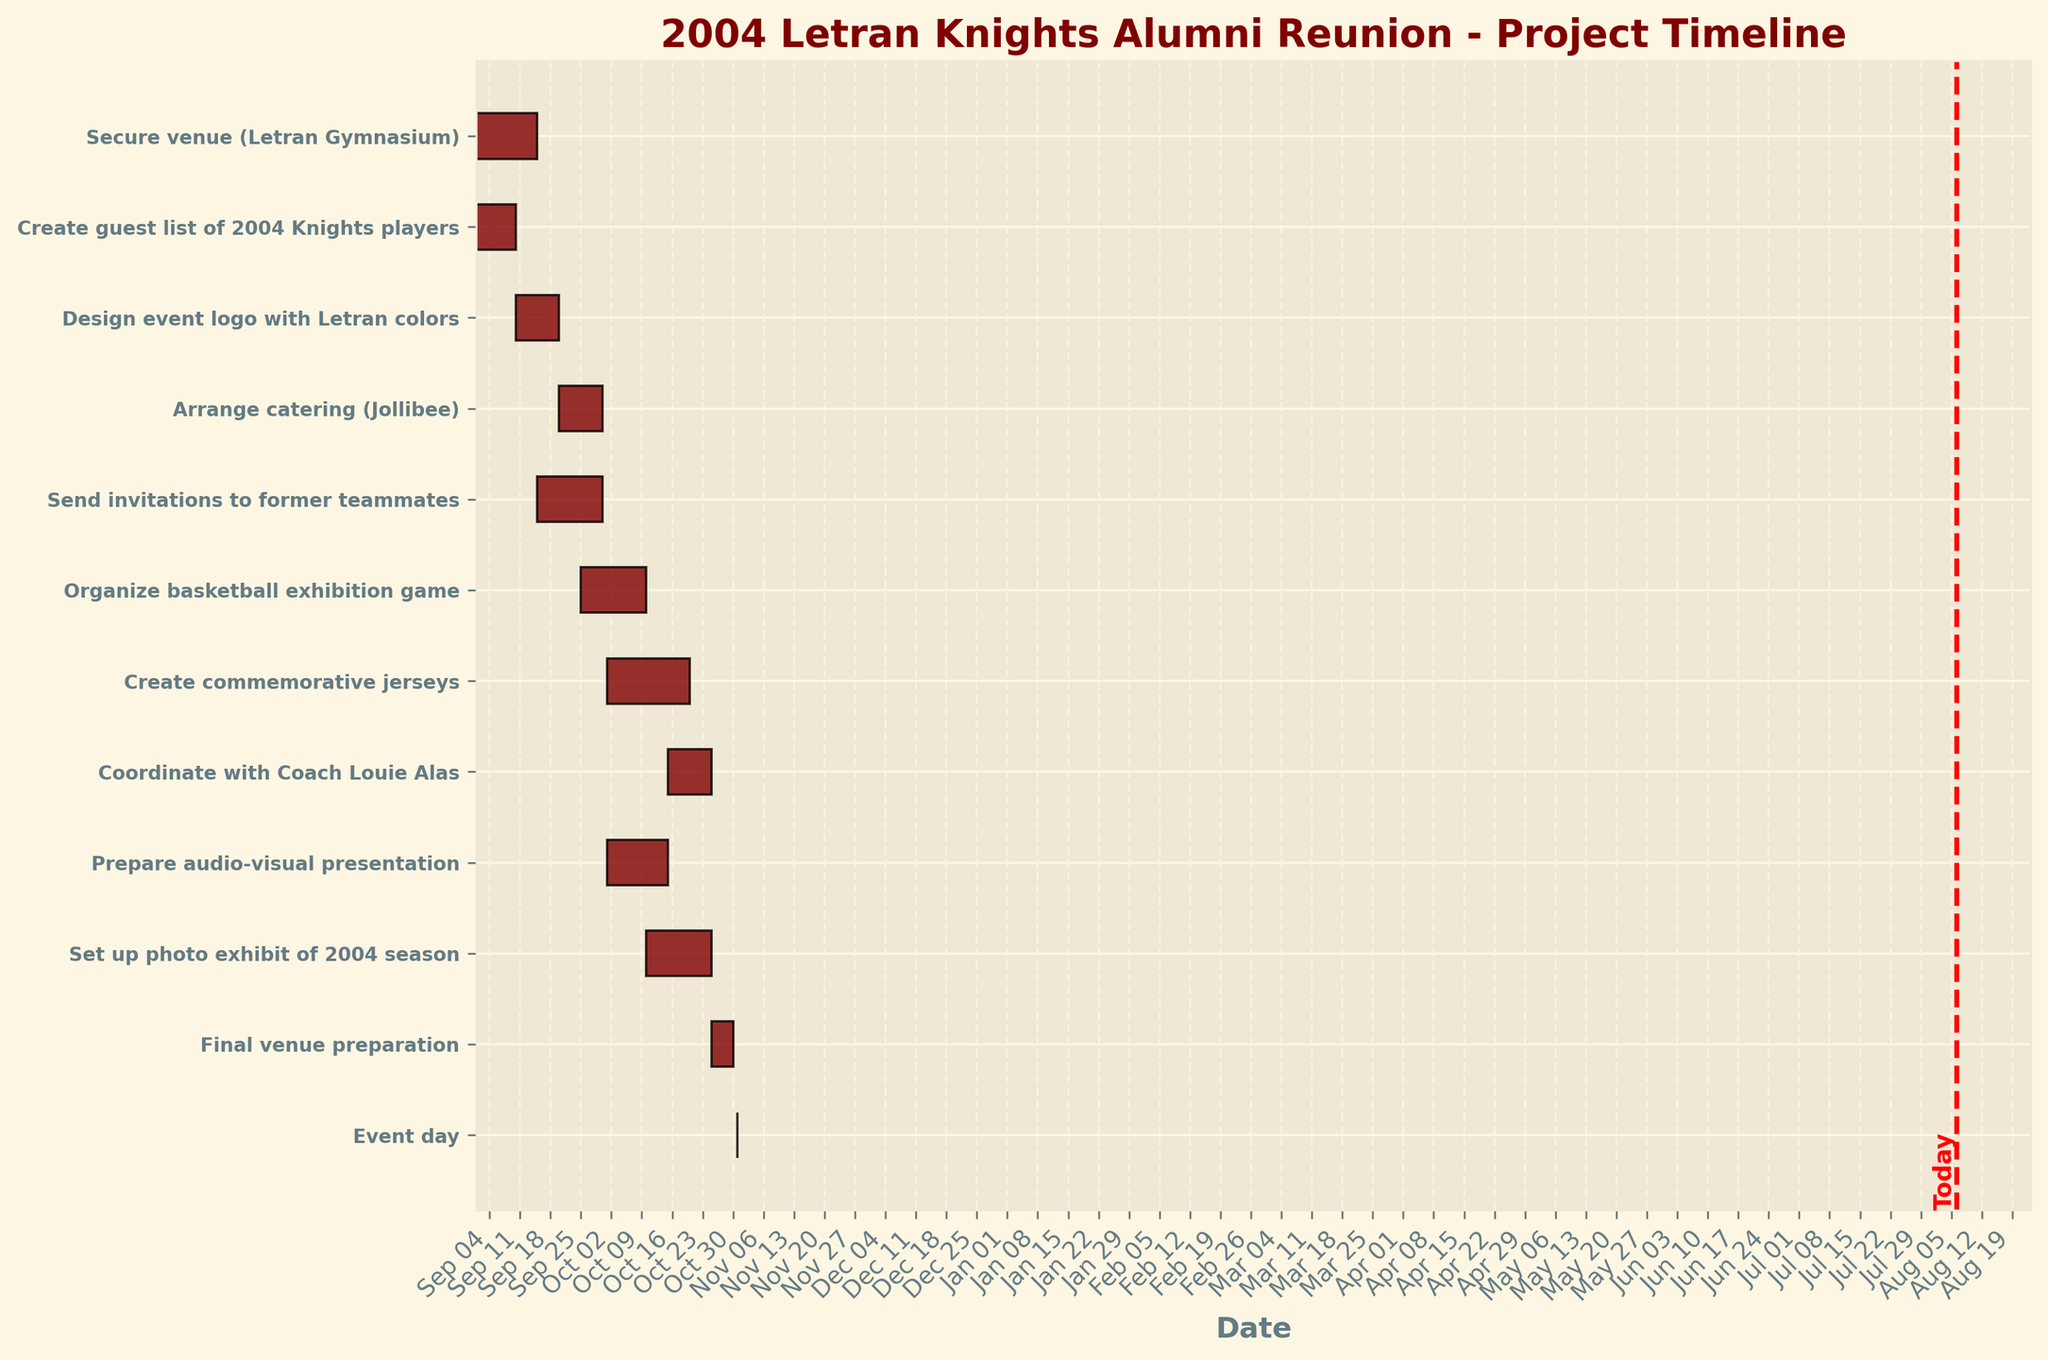What is the title of the Gantt Chart? The title is usually positioned at the top of the chart and is clearly visible. In this case, the title informs us about the chart's subject.
Answer: 2004 Letran Knights Alumni Reunion - Project Timeline On what date does the task "Create guest list of 2004 Knights players" start? The start date is depicted as the beginning of the horizontal bar for this particular task on the y-axis.
Answer: 2023-09-01 Which task has the latest end date? Compare the end dates of each task, finding the one that stretches the farthest to the right on the x-axis.
Answer: Event day Between “Design event logo with Letran colors” and “Send invitations to former teammates,” which task starts later? Look at the start dates of both tasks and compare which bar begins later on the x-axis timeline.
Answer: Send invitations to former teammates How many tasks are ongoing on 2023-10-05? Count the number of bars that intersect with the date 2023-10-05 on the x-axis.
Answer: 2 Which tasks are ongoing during the event day? Identify tasks that extend their duration over or end on the event day, comparing to the event day's position on the x-axis.
Answer: None, only the Event day itself What is the duration in days for the task "Arrange catering (Jollibee)"? Subtract the start date from the end date for the given task to calculate the duration.
Answer: 15 Which task starts on the same day as “Coordinate with Coach Louie Alas”? Look for tasks that begin on the same date as “Coordinate with Coach Louie Alas,” marked on the x-axis.
Answer: Create commemorative jerseys How many tasks overlap with “Organize basketball exhibition game”? Count the number of tasks whose horizontal bars overlap with the “Organize basketball exhibition game” bar on the x-axis.
Answer: 5 Which task immediately follows "Set up photo exhibit of 2004 season"? Identify the task that starts right after the end date of "Set up photo exhibit of 2004 season."
Answer: Prepare audio-visual presentation 